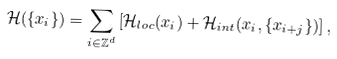Convert formula to latex. <formula><loc_0><loc_0><loc_500><loc_500>\mathcal { H } ( \{ x _ { i } \} ) = \sum _ { i \in \mathbb { Z } ^ { d } } \left [ \mathcal { H } _ { l o c } ( x _ { i } ) + \mathcal { H } _ { i n t } ( x _ { i } , \{ x _ { i + j } \} ) \right ] ,</formula> 